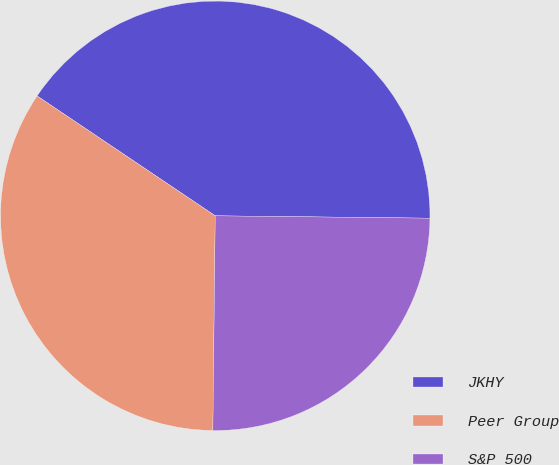Convert chart. <chart><loc_0><loc_0><loc_500><loc_500><pie_chart><fcel>JKHY<fcel>Peer Group<fcel>S&P 500<nl><fcel>40.75%<fcel>34.25%<fcel>25.0%<nl></chart> 